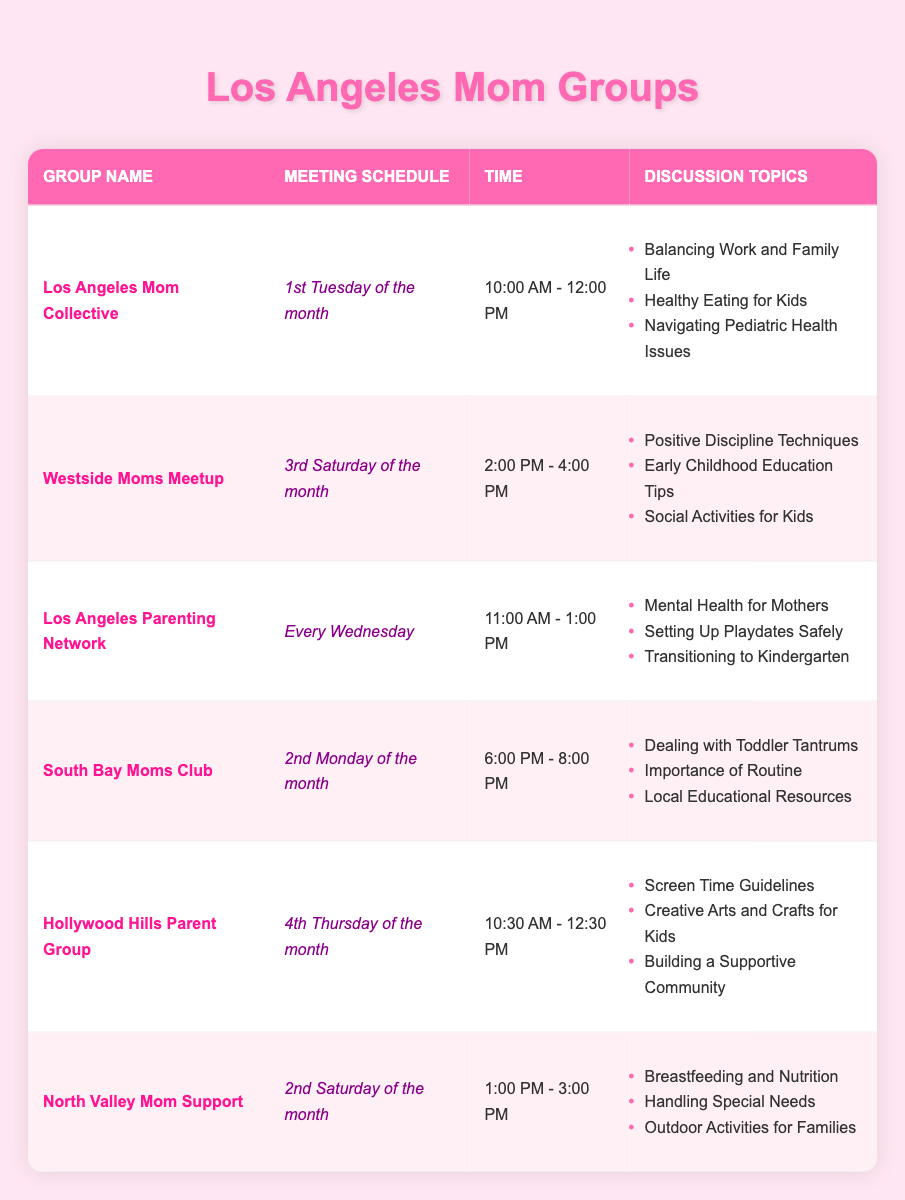What is the meeting time for the Los Angeles Mom Collective? The table shows that the Los Angeles Mom Collective meets from 10:00 AM to 12:00 PM on the 1st Tuesday of the month.
Answer: 10:00 AM - 12:00 PM How often does the South Bay Moms Club meet? By checking the schedule in the table, the South Bay Moms Club meets once a month on the 2nd Monday.
Answer: Once a month Which group discusses 'Navigating Pediatric Health Issues'? The table indicates that 'Navigating Pediatric Health Issues' is a discussion topic for the Los Angeles Mom Collective.
Answer: Los Angeles Mom Collective Is there a parenting group that meets weekly? According to the table, the Los Angeles Parenting Network meets every Wednesday, so yes, there is a group that meets weekly.
Answer: Yes What topics are discussed at the North Valley Mom Support meetings? The North Valley Mom Support group discusses 'Breastfeeding and Nutrition', 'Handling Special Needs', and 'Outdoor Activities for Families' as listed in the table.
Answer: Breastfeeding and Nutrition, Handling Special Needs, Outdoor Activities for Families How many different discussion topics does the Hollywood Hills Parent Group cover? The Hollywood Hills Parent Group has three topics listed: 'Screen Time Guidelines', 'Creative Arts and Crafts for Kids', and 'Building a Supportive Community'. So, the total is three.
Answer: 3 On which day does the Westside Moms Meetup occur? The table shows that the Westside Moms Meetup occurs on the 3rd Saturday of the month.
Answer: 3rd Saturday of the month Which group meets in the afternoon? The Westside Moms Meetup and the South Bay Moms Club schedule their meetings in the afternoon, 2:00 PM - 4:00 PM and 6:00 PM - 8:00 PM, respectively.
Answer: Westside Moms Meetup and South Bay Moms Club What is the earliest meeting time listed in the table? The earliest meeting in the table is for the Los Angeles Mom Collective, which starts at 10:00 AM.
Answer: 10:00 AM Which two groups have overlapping topics about children’s activities? Both the Hollywood Hills Parent Group and the Westside Moms Meetup discuss children’s activities, mentioning 'Creative Arts and Crafts for Kids' and 'Social Activities for Kids', respectively.
Answer: Hollywood Hills Parent Group and Westside Moms Meetup How many total meetings are scheduled for each month across all groups? Adding the unique meetings per group, there are 6 unique meeting schedules (1st Tuesday, 2nd Monday, 3rd Saturday, 4th Thursday, Every Wednesday, 2nd Saturday), indicating 6 unique opportunities for monthly meetings.
Answer: 6 meetings 